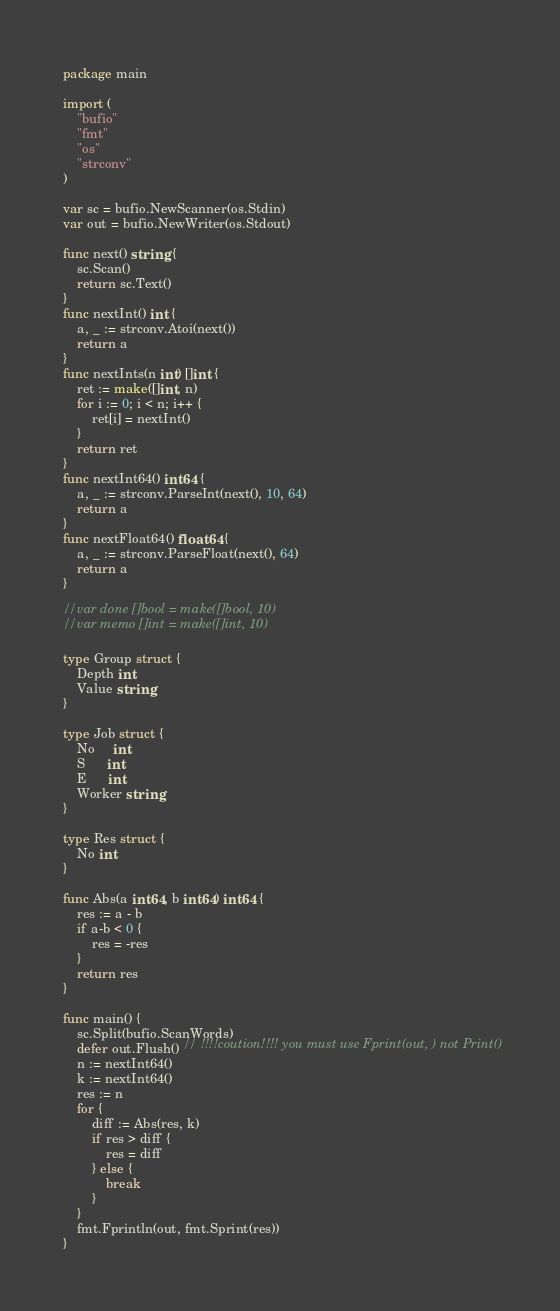<code> <loc_0><loc_0><loc_500><loc_500><_Go_>package main

import (
	"bufio"
	"fmt"
	"os"
	"strconv"
)

var sc = bufio.NewScanner(os.Stdin)
var out = bufio.NewWriter(os.Stdout)

func next() string {
	sc.Scan()
	return sc.Text()
}
func nextInt() int {
	a, _ := strconv.Atoi(next())
	return a
}
func nextInts(n int) []int {
	ret := make([]int, n)
	for i := 0; i < n; i++ {
		ret[i] = nextInt()
	}
	return ret
}
func nextInt64() int64 {
	a, _ := strconv.ParseInt(next(), 10, 64)
	return a
}
func nextFloat64() float64 {
	a, _ := strconv.ParseFloat(next(), 64)
	return a
}

//var done []bool = make([]bool, 10)
//var memo []int = make([]int, 10)

type Group struct {
	Depth int
	Value string
}

type Job struct {
	No     int
	S      int
	E      int
	Worker string
}

type Res struct {
	No int
}

func Abs(a int64, b int64) int64 {
	res := a - b
	if a-b < 0 {
		res = -res
	}
	return res
}

func main() {
	sc.Split(bufio.ScanWords)
	defer out.Flush() // !!!!coution!!!! you must use Fprint(out, ) not Print()
	n := nextInt64()
	k := nextInt64()
	res := n
	for {
		diff := Abs(res, k)
		if res > diff {
			res = diff
		} else {
			break
		}
	}
	fmt.Fprintln(out, fmt.Sprint(res))
}
</code> 